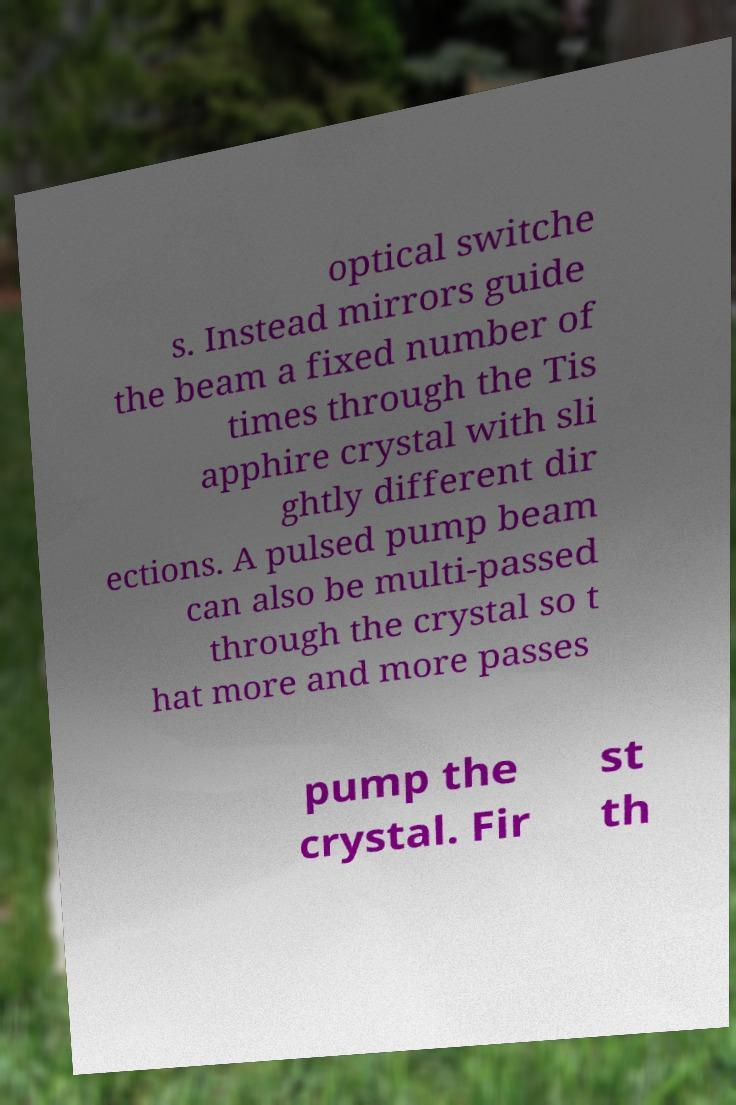I need the written content from this picture converted into text. Can you do that? optical switche s. Instead mirrors guide the beam a fixed number of times through the Tis apphire crystal with sli ghtly different dir ections. A pulsed pump beam can also be multi-passed through the crystal so t hat more and more passes pump the crystal. Fir st th 